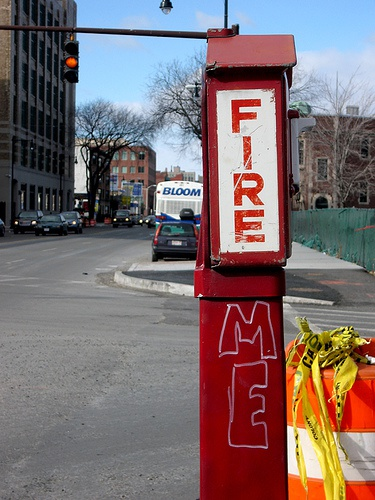Describe the objects in this image and their specific colors. I can see truck in gray, white, darkgray, black, and blue tones, car in gray, black, and teal tones, car in gray, black, blue, and darkblue tones, traffic light in gray, black, red, and brown tones, and car in gray, black, and blue tones in this image. 